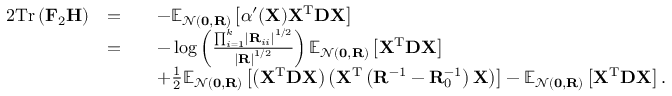Convert formula to latex. <formula><loc_0><loc_0><loc_500><loc_500>\begin{array} { r l r l } { { 2 } T r \left ( F _ { 2 } H \right ) } & { = } & & { - \mathbb { E } _ { \mathcal { N } ( 0 , R ) } \left [ \alpha ^ { \prime } ( X ) X ^ { T } D X \right ] } \\ & { = } & & { - \log \left ( \frac { \prod _ { i = 1 } ^ { k } \left | R _ { i i } \right | ^ { 1 / 2 } } { \left | R \right | ^ { 1 / 2 } } \right ) \mathbb { E } _ { \mathcal { N } ( 0 , R ) } \left [ X ^ { T } D X \right ] } \\ & & { + \frac { 1 } { 2 } \mathbb { E } _ { \mathcal { N } ( 0 , R ) } \left [ \left ( X ^ { T } D X \right ) \left ( X ^ { T } \left ( R ^ { - 1 } - R _ { 0 } ^ { - 1 } \right ) X \right ) \right ] - \mathbb { E } _ { \mathcal { N } ( 0 , R ) } \left [ X ^ { T } D X \right ] . } \end{array}</formula> 